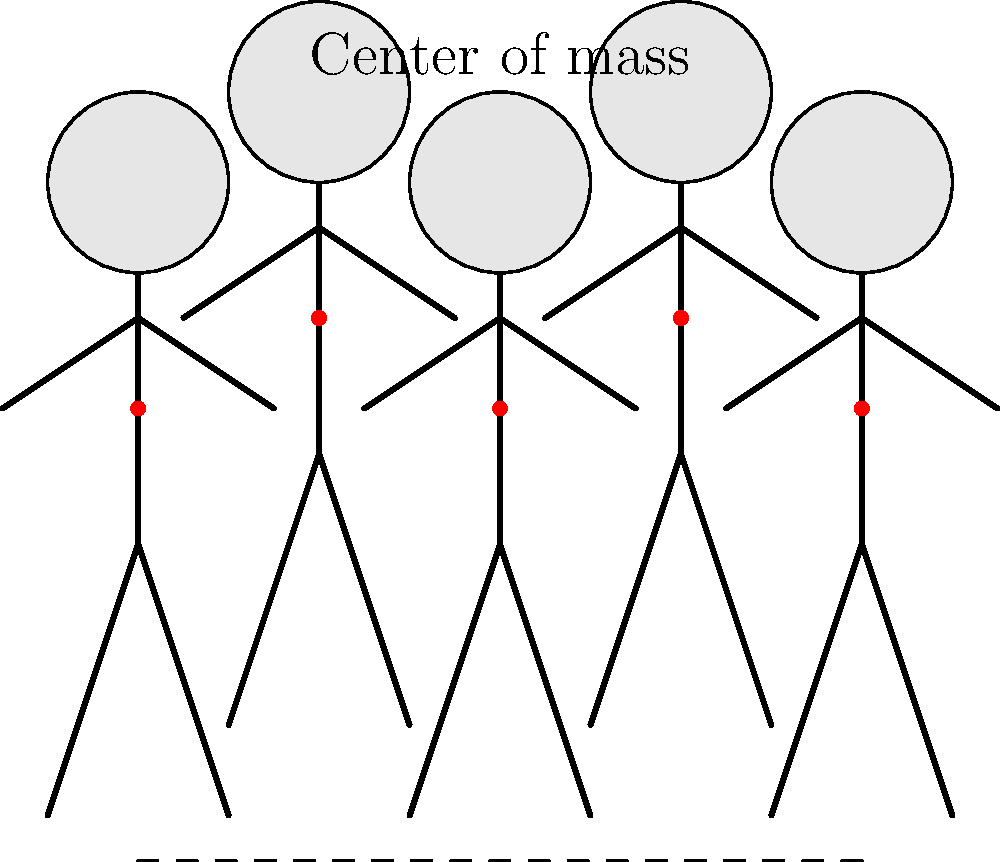In the virtual character's walking animation shown above, how does the center of mass (indicated by the red dot) shift during a complete gait cycle? Describe the pattern and its implications for realistic VR character movement. To analyze the center of mass shift during the virtual character's walking animation:

1. Observe the red dots: These represent the center of mass for each position in the gait cycle.

2. Identify the pattern: The center of mass follows a sinusoidal path as the character walks.

3. Vertical movement:
   - The center of mass is highest when the supporting leg is straight and directly under the body (positions 2 and 4).
   - It's lowest when both feet are on the ground and the legs are spread (positions 1, 3, and 5).

4. Horizontal movement:
   - The center of mass moves forward continuously but at varying speeds.
   - It moves fastest when transitioning between steps and slowest at the middle of each step.

5. Biomechanical implications:
   - This sinusoidal movement is crucial for energy-efficient walking in real humans.
   - It minimizes the vertical displacement of the body, reducing the energy required to overcome gravity.

6. VR character realism:
   - Implementing this center of mass shift in VR characters enhances the perceived naturalness of their gait.
   - It contributes to the overall believability of the virtual environment.

7. Potential VR interactions:
   - This movement pattern could affect how virtual objects interact with the character.
   - It may influence the design of VR gameplay mechanics involving character movement or balance.

Understanding and implementing this center of mass shift is crucial for creating realistic and immersive VR character animations.
Answer: Sinusoidal pattern; highest at midstance, lowest during double support; crucial for realism and energy efficiency in VR character movement. 